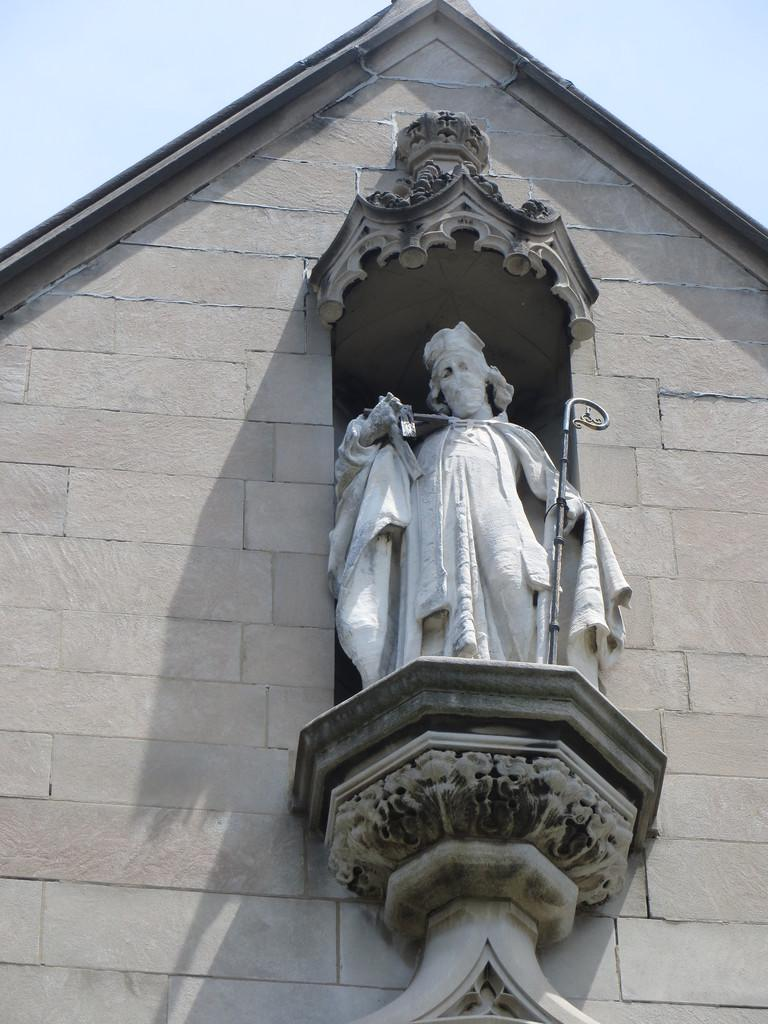What type of structure is featured in the image? There is a historical building wall in the image. What is on the wall? There is a sculpture on the wall. What does the sculpture depict? The sculpture depicts a man holding a stick. What can be seen in the background of the image? The sky is visible in the background of the image. How much money is the man holding in the sculpture? The sculpture does not depict the man holding money; he is holding a stick. 